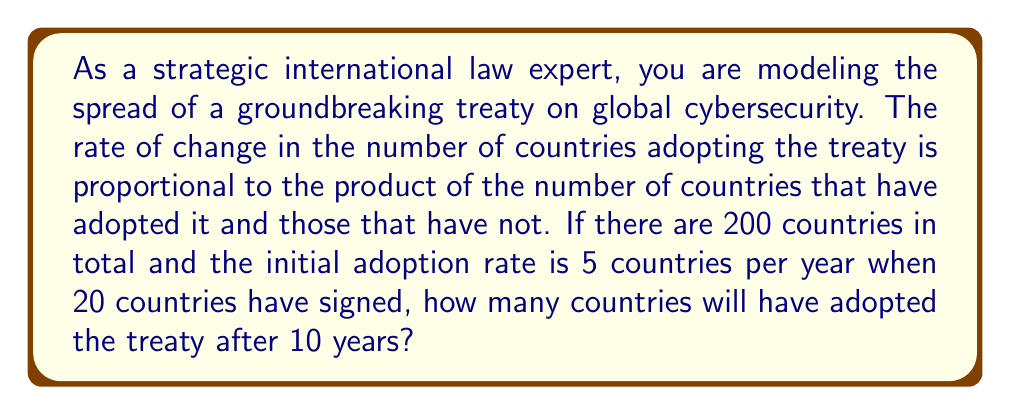Can you answer this question? Let's approach this step-by-step using a logistic growth model:

1) Let $P(t)$ be the number of countries that have adopted the treaty at time $t$.

2) The differential equation for this model is:
   $$\frac{dP}{dt} = kP(200-P)$$
   where $k$ is a constant and 200 is the total number of countries.

3) We're given that when $P = 20$, $\frac{dP}{dt} = 5$. Let's use this to find $k$:
   $$5 = k \cdot 20 \cdot (200-20)$$
   $$5 = 3600k$$
   $$k = \frac{5}{3600} = \frac{1}{720}$$

4) Now our differential equation is:
   $$\frac{dP}{dt} = \frac{1}{720}P(200-P)$$

5) The solution to this logistic equation is:
   $$P(t) = \frac{200}{1 + Ce^{-\frac{t}{3.6}}}$$
   where $C$ is a constant we need to determine.

6) At $t=0$, $P(0) = 20$. Let's use this to find $C$:
   $$20 = \frac{200}{1 + C}$$
   $$C = 9$$

7) So our final equation is:
   $$P(t) = \frac{200}{1 + 9e^{-\frac{t}{3.6}}}$$

8) To find $P(10)$, we substitute $t=10$:
   $$P(10) = \frac{200}{1 + 9e^{-\frac{10}{3.6}}} \approx 70.96$$

9) Rounding to the nearest whole number (as we can't have fractional countries), we get 71 countries.
Answer: 71 countries 